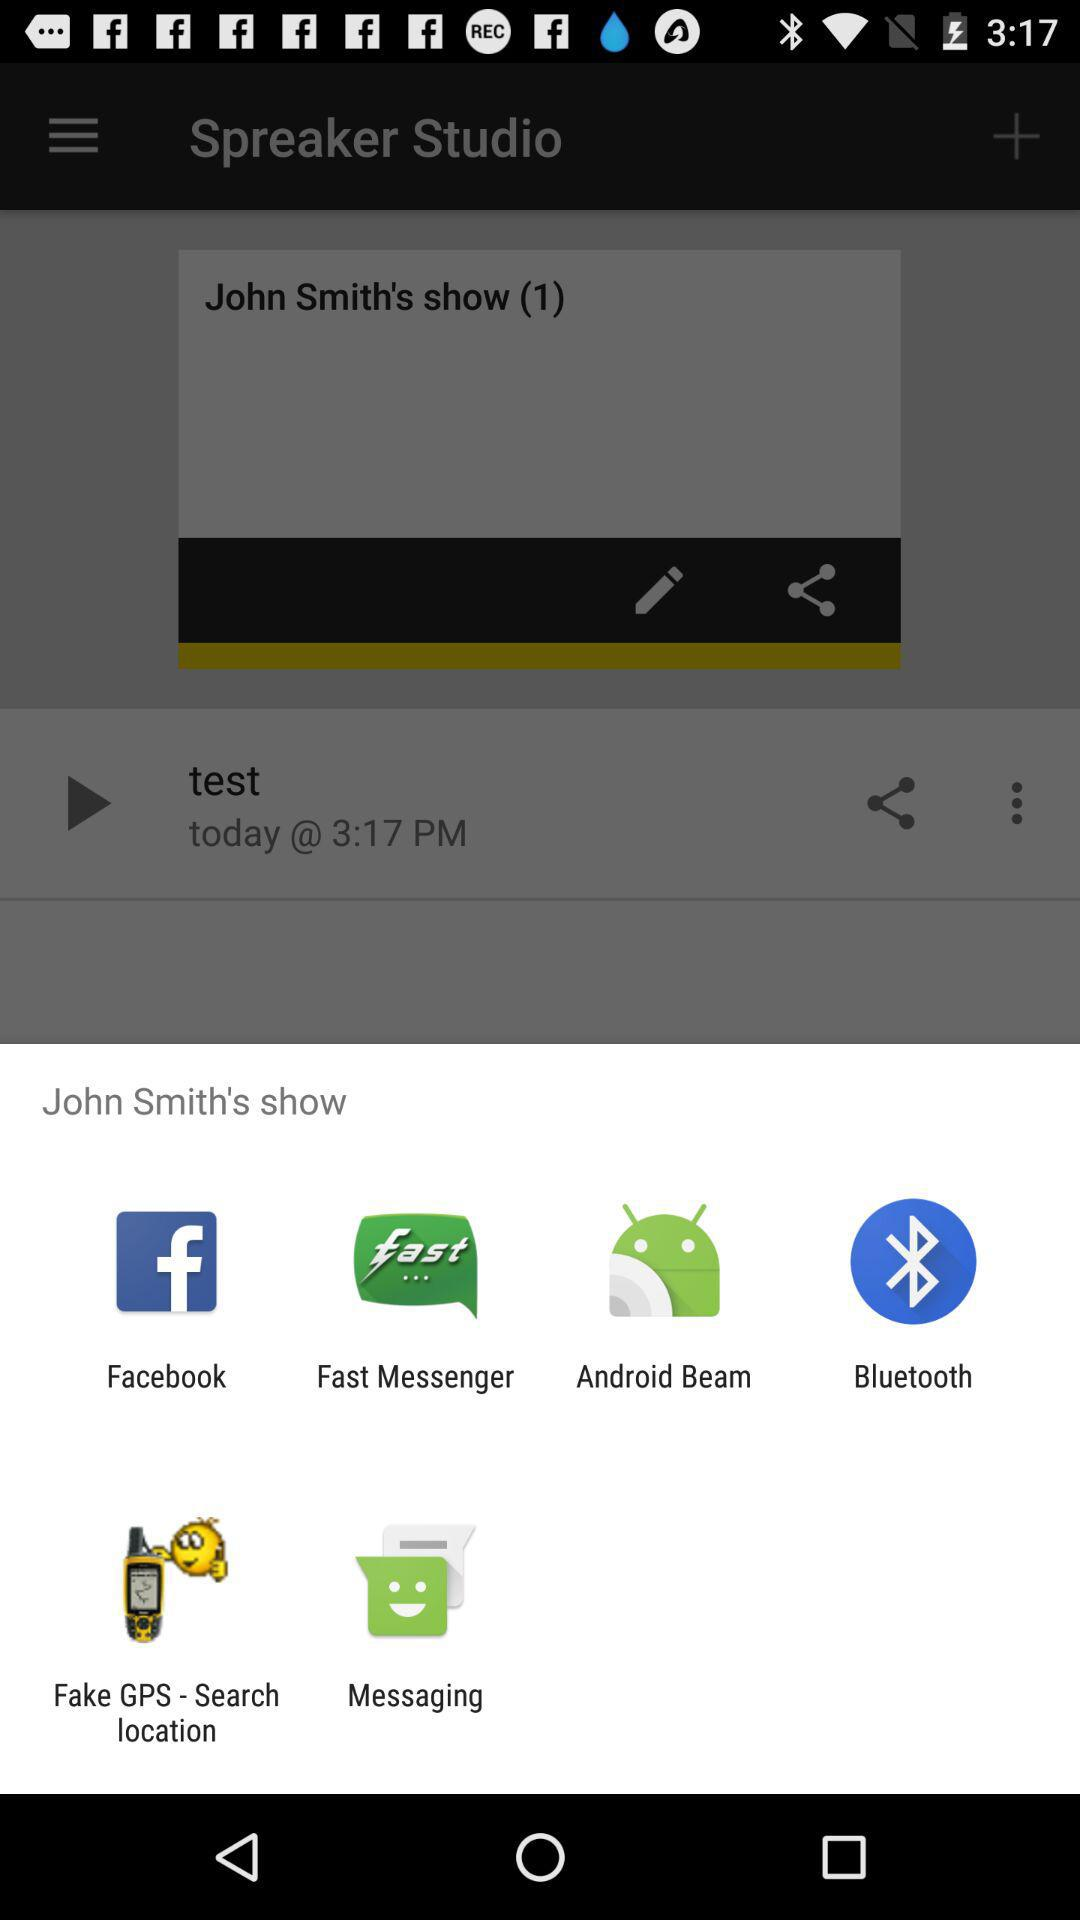What are the sharing options? The sharing options are "Facebook", "Fast Messenger", "Android Beam", "Bluetooth", "Fake GPS - Search location", and "Messaging". 